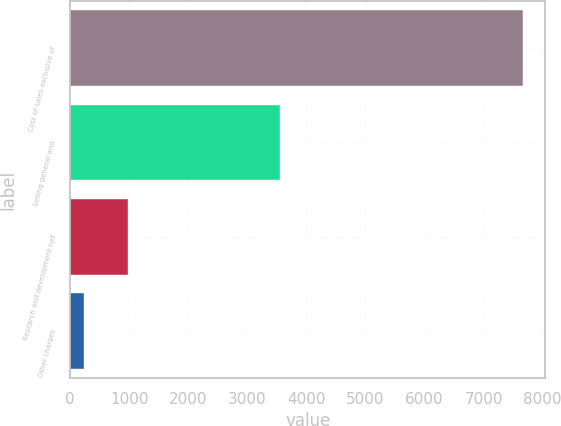Convert chart. <chart><loc_0><loc_0><loc_500><loc_500><bar_chart><fcel>Cost of sales exclusive of<fcel>Selling general and<fcel>Research and development net<fcel>Other charges<nl><fcel>7665<fcel>3555<fcel>984.3<fcel>242<nl></chart> 